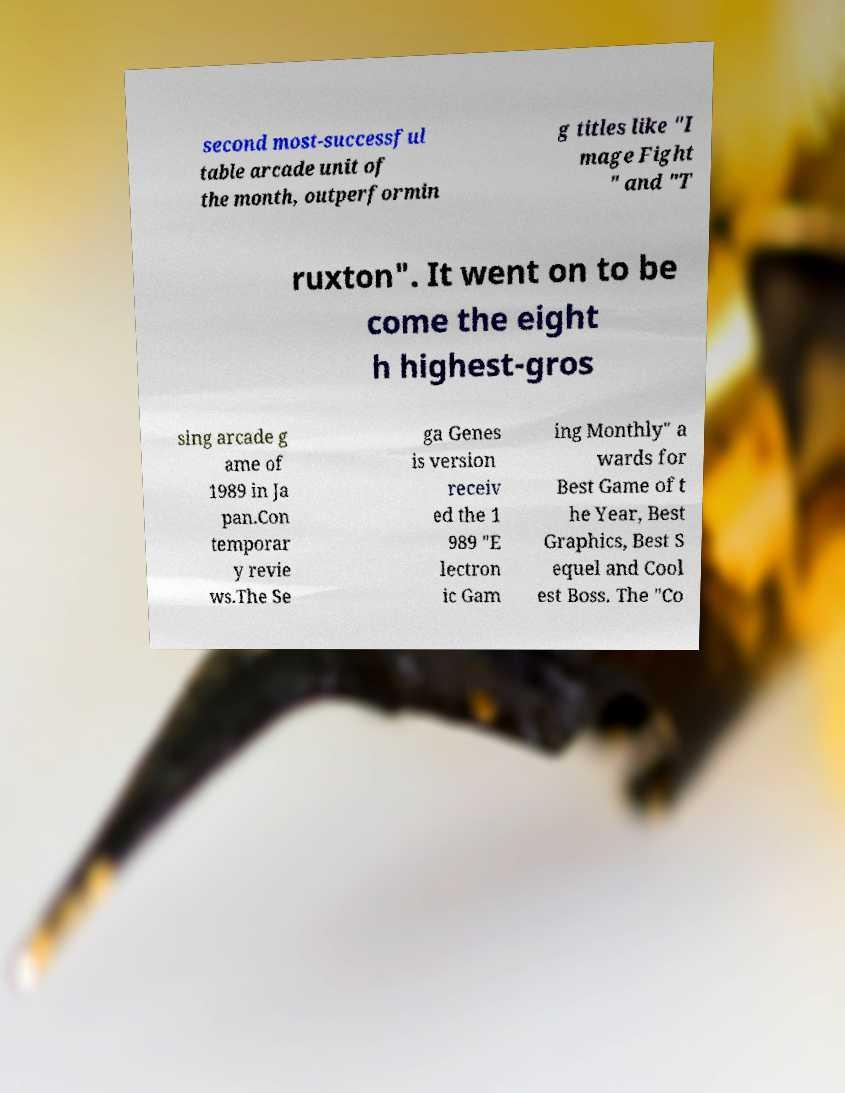Please identify and transcribe the text found in this image. second most-successful table arcade unit of the month, outperformin g titles like "I mage Fight " and "T ruxton". It went on to be come the eight h highest-gros sing arcade g ame of 1989 in Ja pan.Con temporar y revie ws.The Se ga Genes is version receiv ed the 1 989 "E lectron ic Gam ing Monthly" a wards for Best Game of t he Year, Best Graphics, Best S equel and Cool est Boss. The "Co 